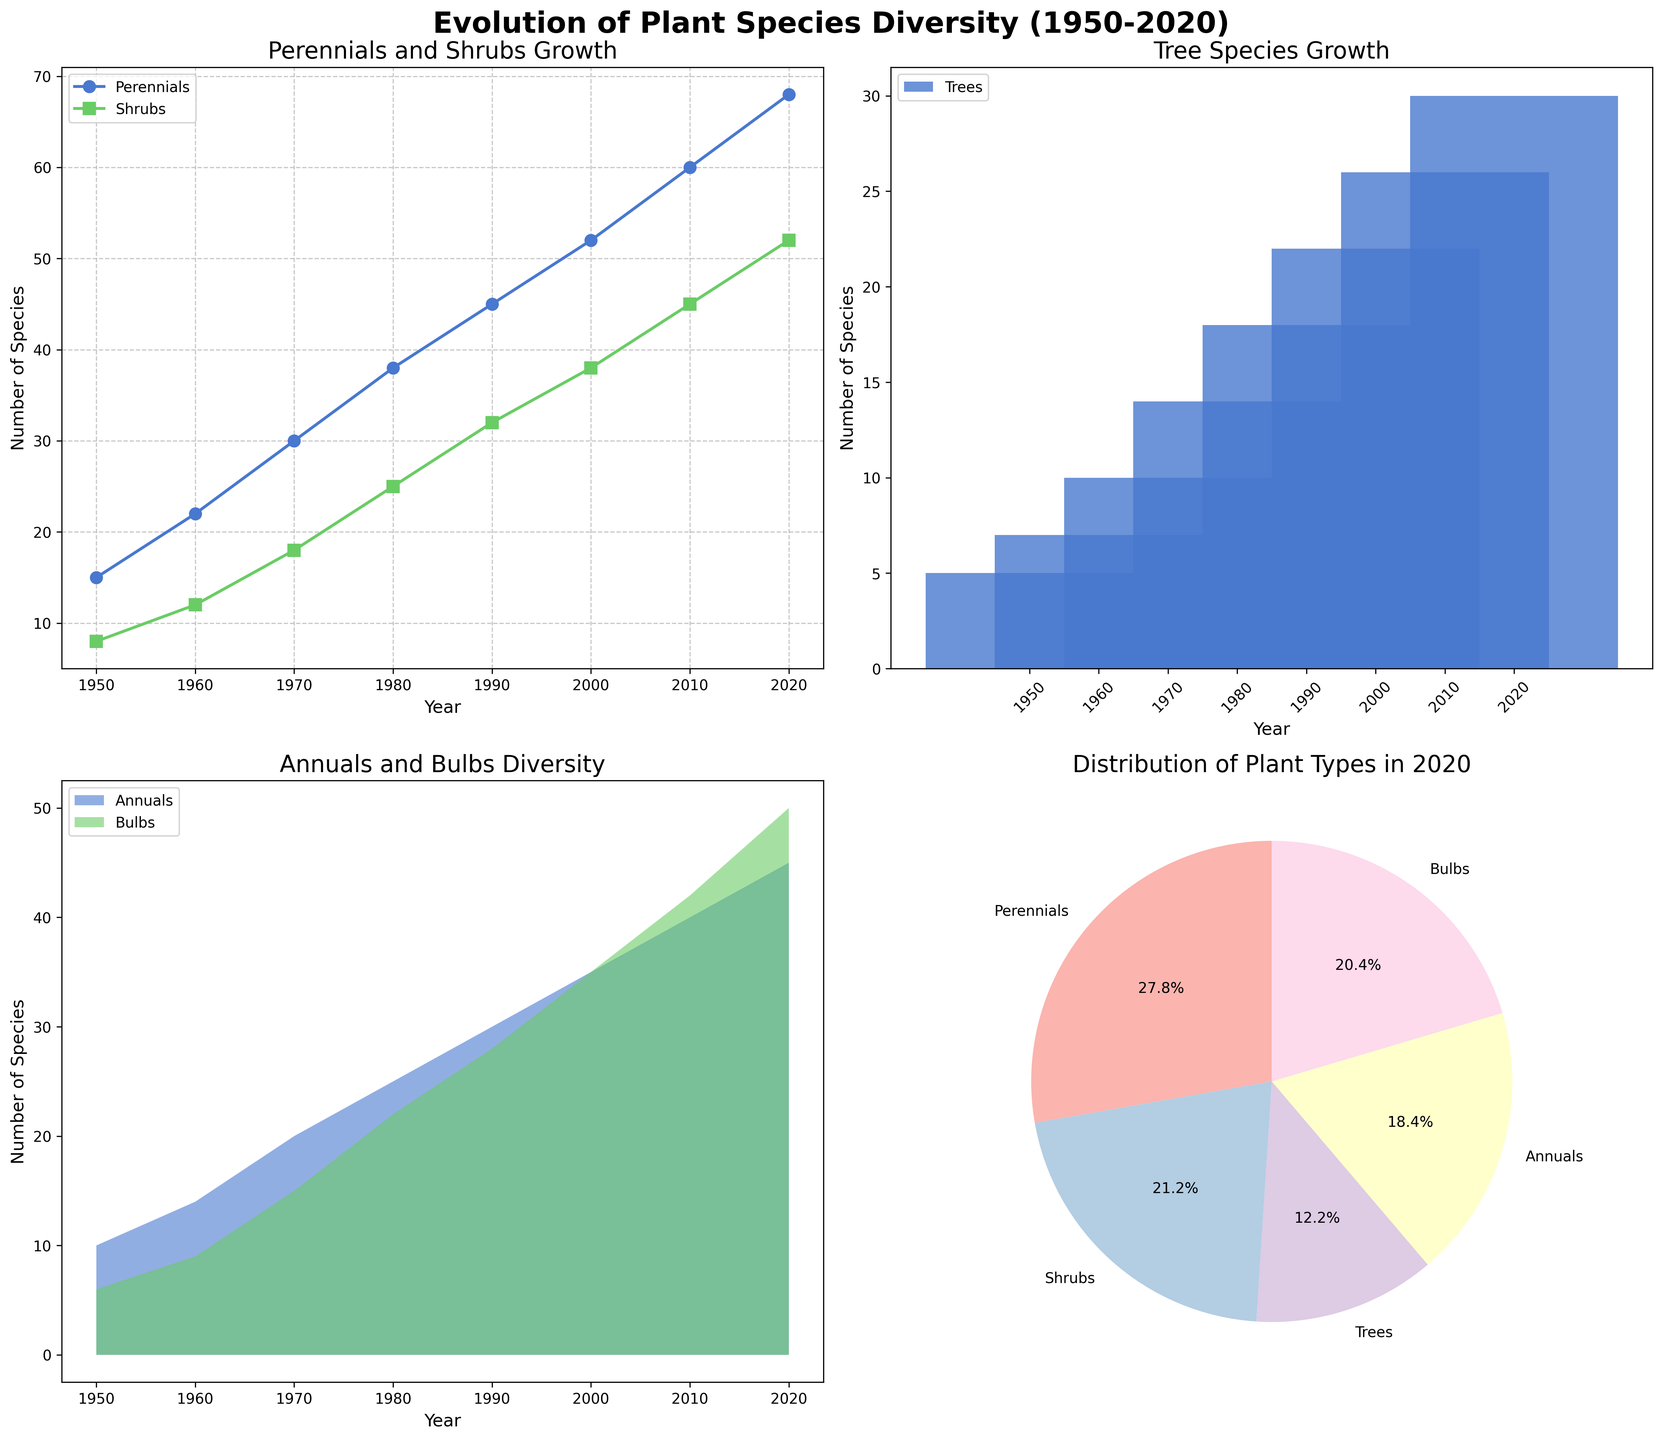What's the title of the entire figure? The title is located at the top of the entire figure and provides a summary of the figure's content, indicating it is about the change in plant species diversity from 1950 to 2020.
Answer: Evolution of Plant Species Diversity (1950-2020) How many species of Perennials were there in 1980? Refer to the line plot in the top left corner. The point for Perennials in 1980 lines up with the Y-axis value for that year.
Answer: 38 Which year has the highest number of Shrubs? Look at the line plot in the top left corner, follow the Shrubs line (represented by square markers) to find the peak value.
Answer: 2020 What's the Y-axis label of the stacked area plot? The Y-axis label specifies the type of data measured in the plot. For the stacked area plot of Annuals and Bulbs, this label is located along the left vertical axis.
Answer: Number of Species Compare the number of Tree species between 2000 and 2010. Which year had more? In the bar plot, compare the heights of the bars for 2000 and 2010. The bar with the greater height represents the year with more species.
Answer: 2010 What percentage of plant species were Bulbs in 2020? Check the pie chart in the bottom right. The segment with the label 'Bulbs' shows its percentage contribution to the total plant species in 2020.
Answer: 19.2% In which decade did Annuals see the fastest growth? Look at the difference in the values of Annuals in the stacked area plot. The steepest increase between decades indicates the fastest growth.
Answer: 1970-1980 Which plant type had the smallest increase in species from 1950 to 1960? Observe all the plots and compare the number of each plant type in both 1950 and 1960. Calculate the increase by subtracting the 1950 value from the 1960 value for each plant type.
Answer: Trees How does the growth pattern of Perennials compare to Shrubs? Look at the line plot and observe the relative slopes of the lines for Perennials (circular markers) and Shrubs (square markers). Compare how these lines change over the years.
Answer: The growth pattern of Perennials shows a consistently higher increase compared to Shrubs over the decades What does the pie chart tell us about the distribution of plant types in 2020? The pie chart segments indicate the proportion of each plant type relative to the whole in 2020. This shows how plant diversity is distributed among different types.
Answer: More diverse with higher proportions of Perennials and Annuals 